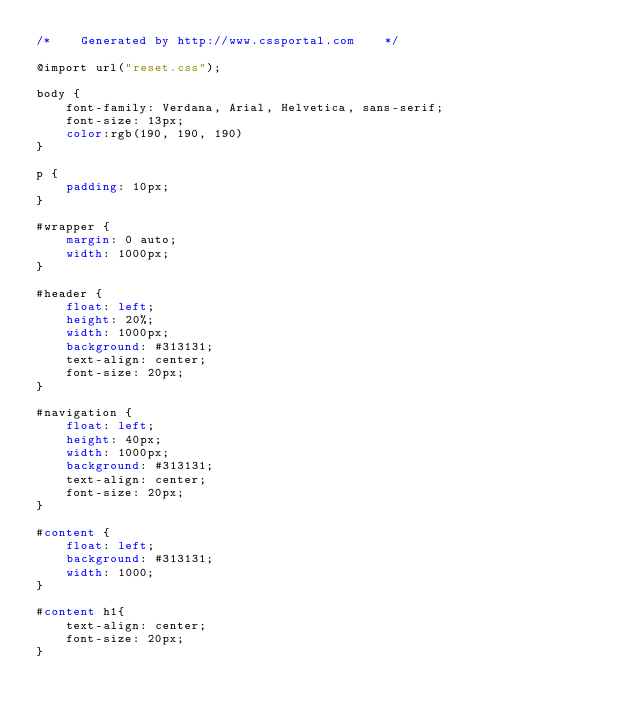<code> <loc_0><loc_0><loc_500><loc_500><_CSS_>/*    Generated by http://www.cssportal.com    */

@import url("reset.css");

body {
    font-family: Verdana, Arial, Helvetica, sans-serif;
    font-size: 13px;
    color:rgb(190, 190, 190)
}

p {
    padding: 10px;
}

#wrapper {
    margin: 0 auto;
    width: 1000px;
}

#header {
    float: left;
    height: 20%;
    width: 1000px;
    background: #313131;
    text-align: center;
    font-size: 20px;
}

#navigation {
    float: left;
    height: 40px;
    width: 1000px;
    background: #313131;
    text-align: center;
    font-size: 20px;    
}

#content {
    float: left;
    background: #313131;
    width: 1000;
}

#content h1{
    text-align: center;
    font-size: 20px;    
}
</code> 